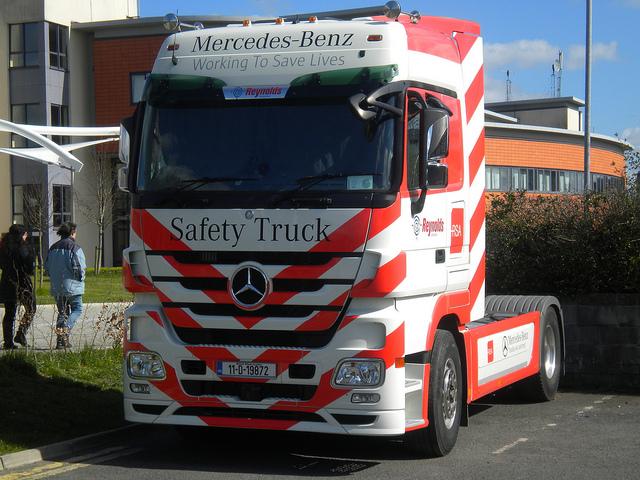Is there a trailer attached to the truck?
Keep it brief. No. Who is the maker of this truck?
Be succinct. Mercedes. What color is the truck?
Answer briefly. Red and white. 